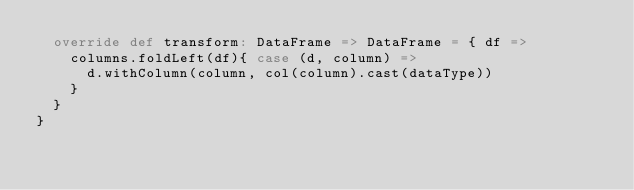<code> <loc_0><loc_0><loc_500><loc_500><_Scala_>  override def transform: DataFrame => DataFrame = { df =>
    columns.foldLeft(df){ case (d, column) =>
      d.withColumn(column, col(column).cast(dataType))
    }
  }
}

</code> 